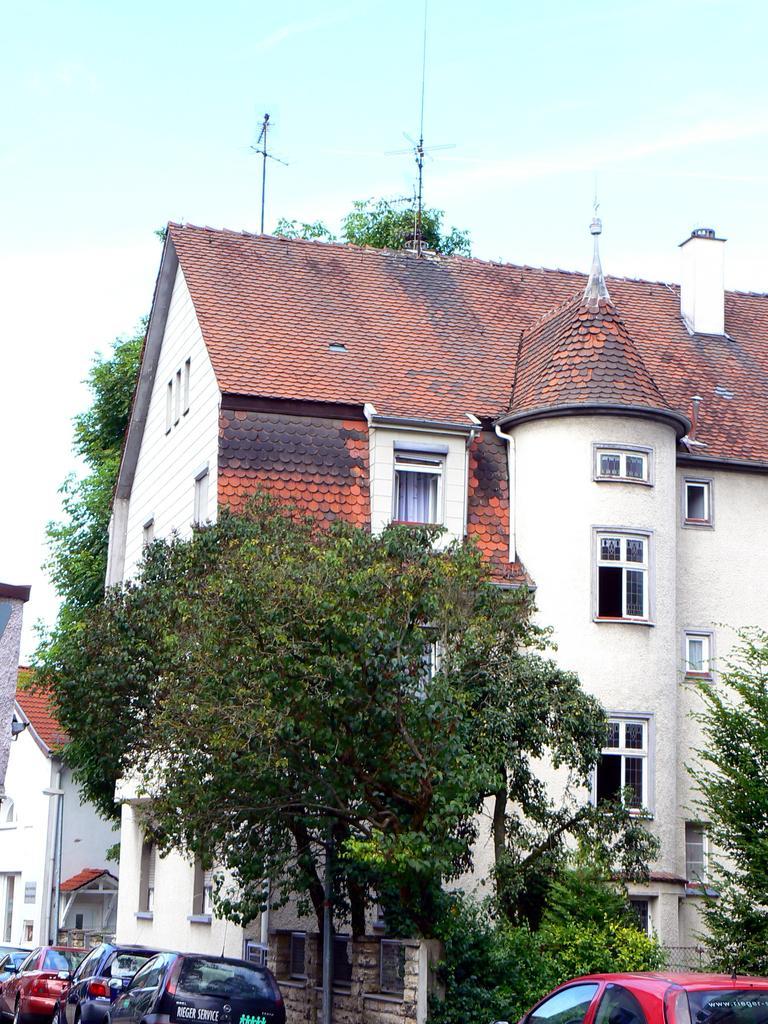Please provide a concise description of this image. This picture shows couple of buildings and we see trees and few cars parked and a blue cloudy sky. 